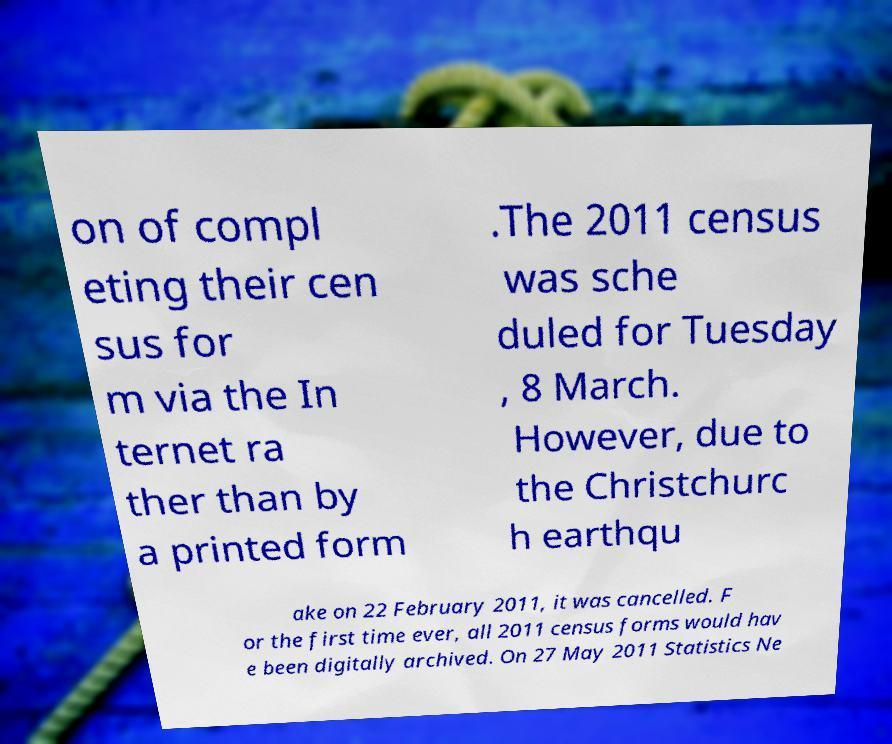Can you accurately transcribe the text from the provided image for me? on of compl eting their cen sus for m via the In ternet ra ther than by a printed form .The 2011 census was sche duled for Tuesday , 8 March. However, due to the Christchurc h earthqu ake on 22 February 2011, it was cancelled. F or the first time ever, all 2011 census forms would hav e been digitally archived. On 27 May 2011 Statistics Ne 